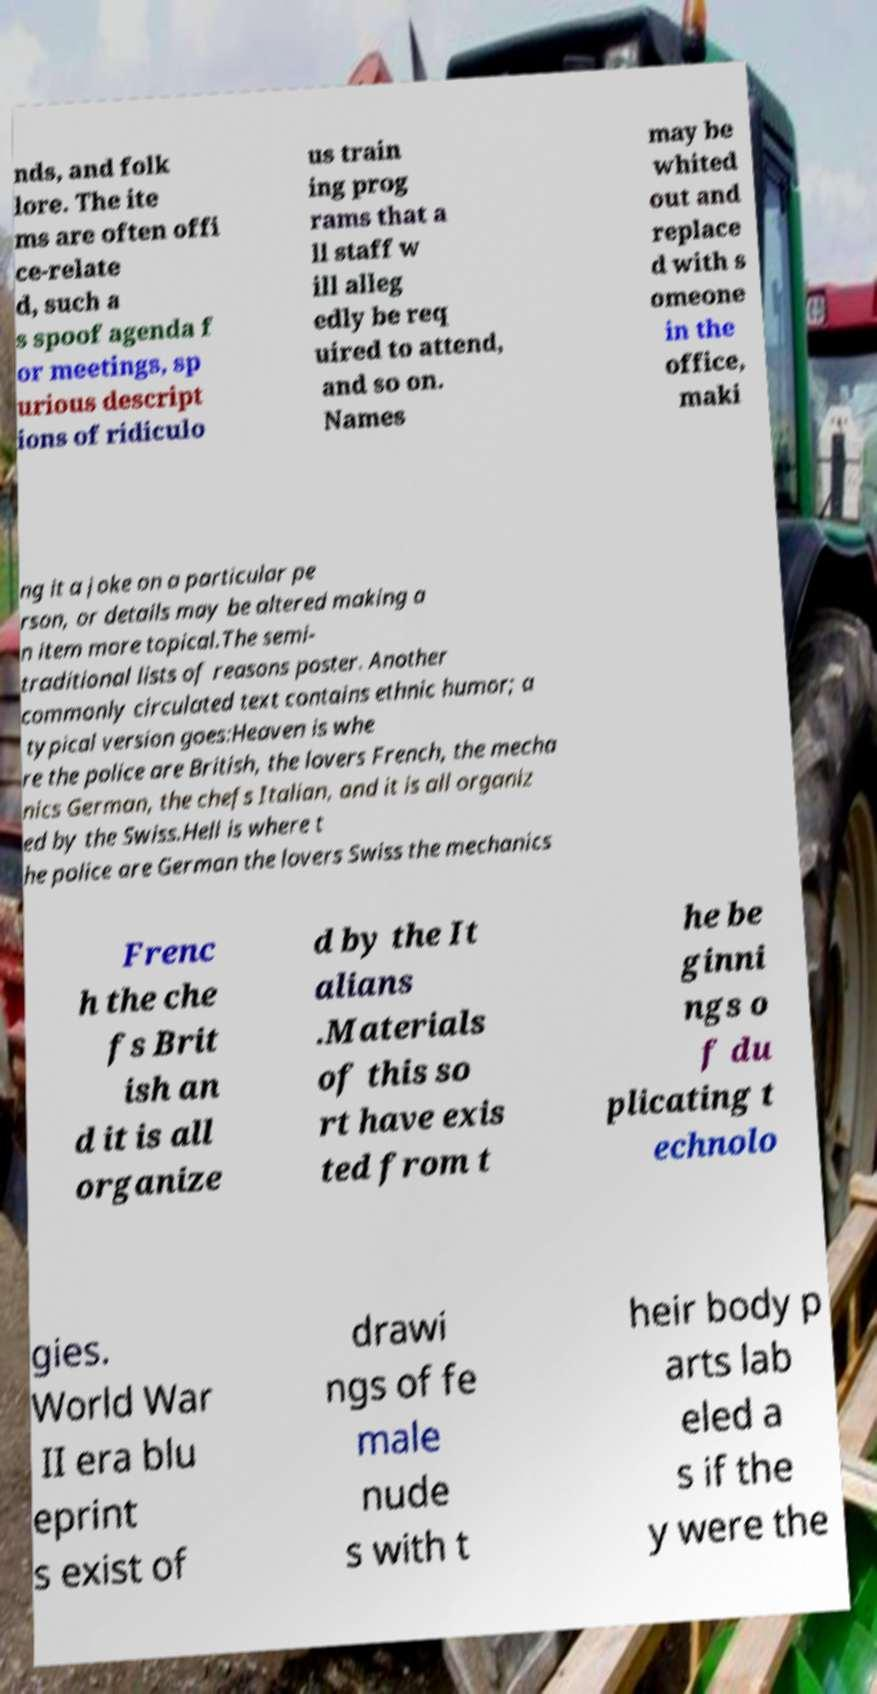Please identify and transcribe the text found in this image. nds, and folk lore. The ite ms are often offi ce-relate d, such a s spoof agenda f or meetings, sp urious descript ions of ridiculo us train ing prog rams that a ll staff w ill alleg edly be req uired to attend, and so on. Names may be whited out and replace d with s omeone in the office, maki ng it a joke on a particular pe rson, or details may be altered making a n item more topical.The semi- traditional lists of reasons poster. Another commonly circulated text contains ethnic humor; a typical version goes:Heaven is whe re the police are British, the lovers French, the mecha nics German, the chefs Italian, and it is all organiz ed by the Swiss.Hell is where t he police are German the lovers Swiss the mechanics Frenc h the che fs Brit ish an d it is all organize d by the It alians .Materials of this so rt have exis ted from t he be ginni ngs o f du plicating t echnolo gies. World War II era blu eprint s exist of drawi ngs of fe male nude s with t heir body p arts lab eled a s if the y were the 